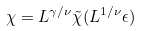<formula> <loc_0><loc_0><loc_500><loc_500>\chi = L ^ { \gamma / \nu } \tilde { \chi } ( L ^ { 1 / \nu } \epsilon )</formula> 